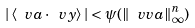<formula> <loc_0><loc_0><loc_500><loc_500>| \, \langle \ v a \cdot \ v y \rangle \, | < \psi ( \| \ v v a \| _ { \infty } ^ { n } )</formula> 